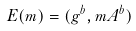<formula> <loc_0><loc_0><loc_500><loc_500>E ( m ) = ( g ^ { b } , m A ^ { b } )</formula> 